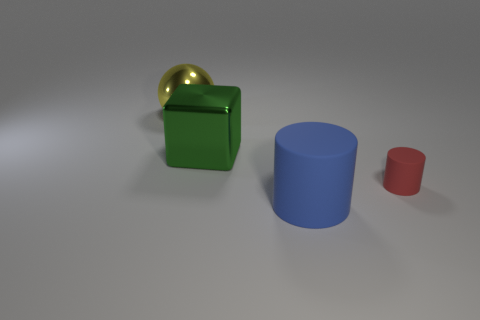Add 1 small brown cubes. How many objects exist? 5 Add 1 large cyan metal balls. How many large cyan metal balls exist? 1 Subtract 0 brown cylinders. How many objects are left? 4 Subtract all blocks. Subtract all large metallic objects. How many objects are left? 1 Add 4 cubes. How many cubes are left? 5 